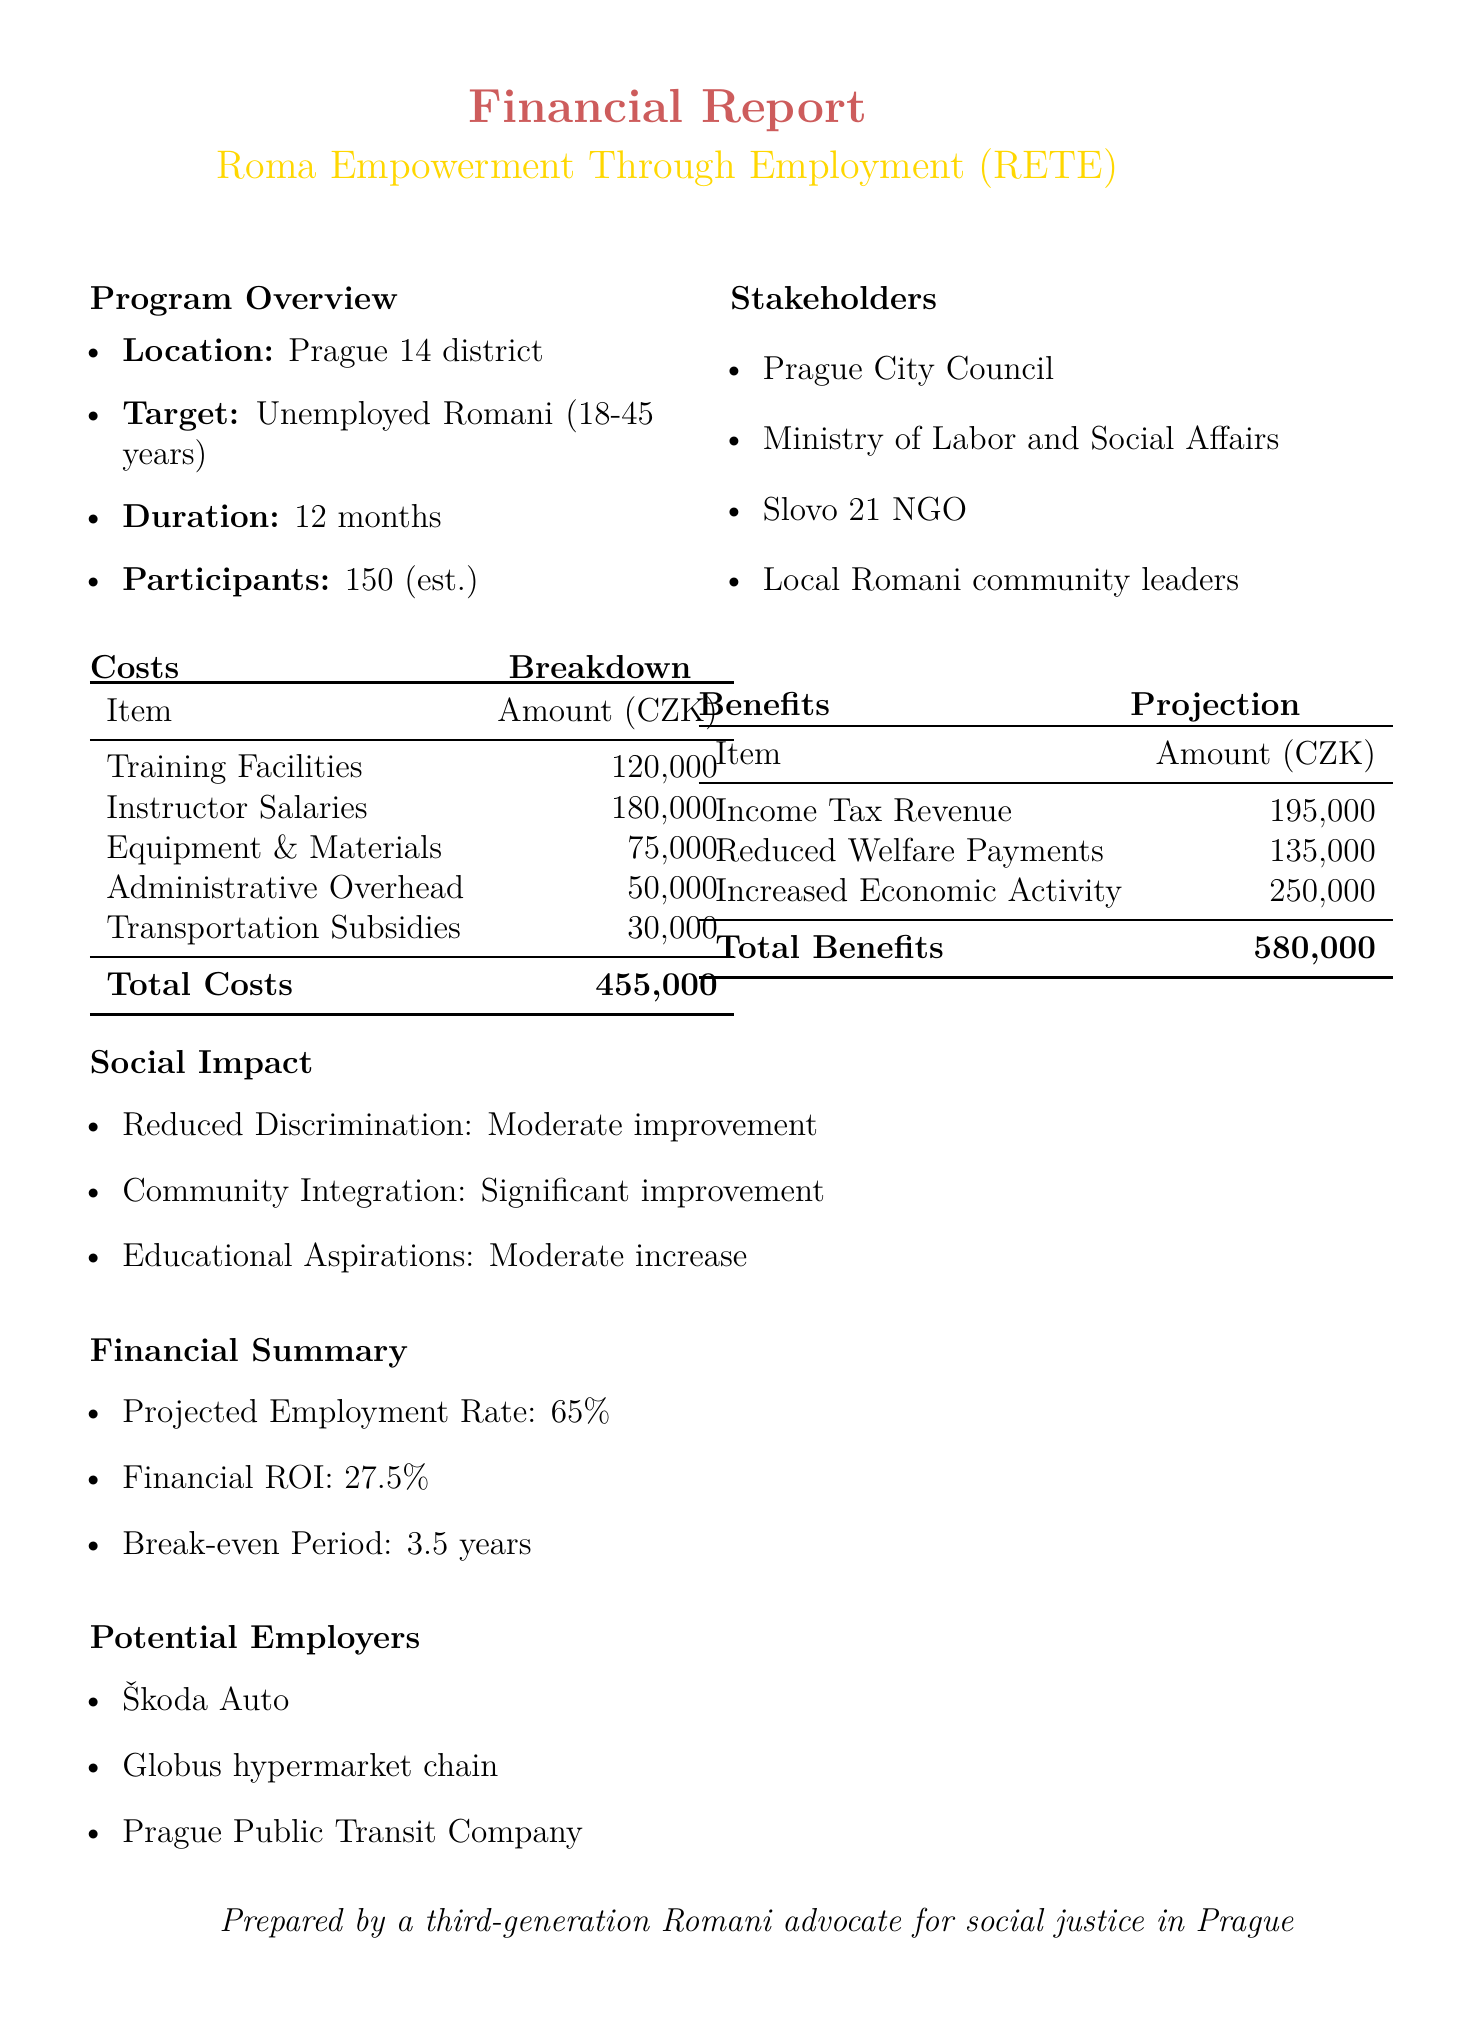What is the program name? The program name is provided in the document under the title.
Answer: Roma Empowerment Through Employment (RETE) What is the estimated total cost of the program? The total cost is detailed in the costs breakdown section of the document.
Answer: 455000 What is the projected employment rate? The projected employment rate can be found in the financial summary section of the report.
Answer: 65% Who are the potential employers listed? The names of potential employers are outlined in the list towards the end of the document.
Answer: Škoda Auto, Globus hypermarket chain, Prague Public Transit Company What is the break-even period? This information is found in the financial summary, providing insight into when costs will be recouped.
Answer: 3.5 years What is the total benefits amount? The total benefits amount is referenced in the benefits projection table.
Answer: 580000 How many estimated participants are there? The estimated number of participants is mentioned in the program overview section of the report.
Answer: 150 What improvement is noted in community integration? The social impact section includes descriptions of improvements, including community integration.
Answer: Significant improvement How much is the projected annual income tax revenue? The projected annual income tax revenue is specified in the benefits projection table of the document.
Answer: 195000 